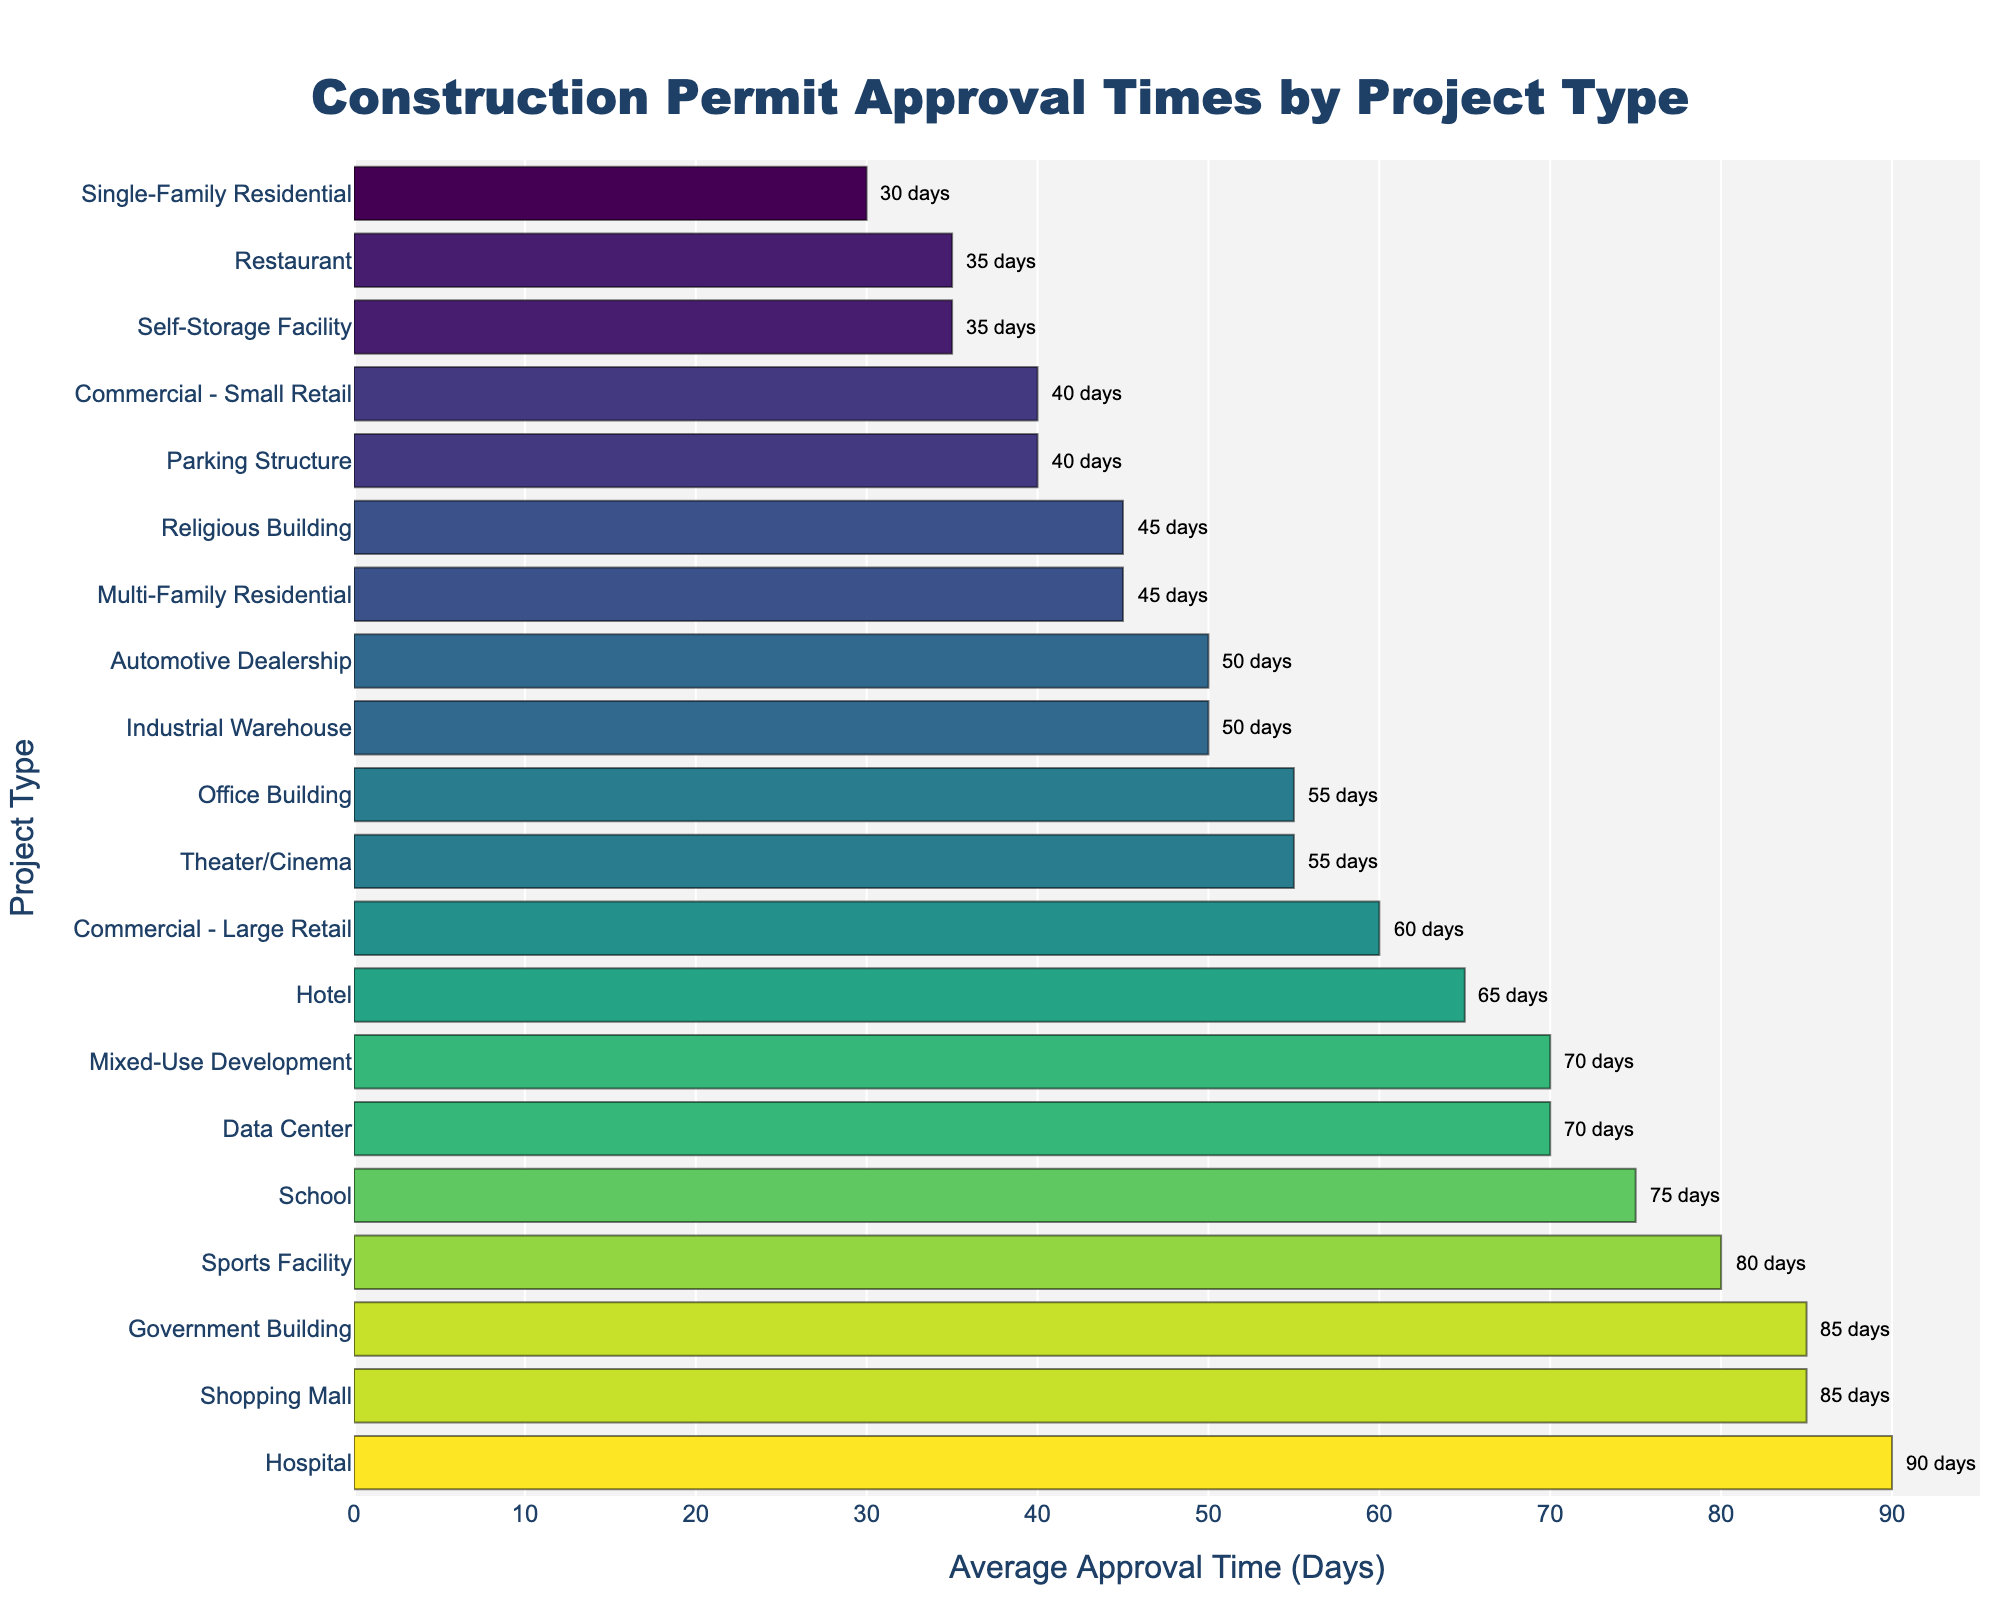Which project type has the shortest average approval time? The figure shows the average approval times for various project types, with the shortest bar representing the shortest time. Single-Family Residential has the shortest approval time at 30 days.
Answer: Single-Family Residential Which project type has the longest average approval time? By looking at the longest bar in the figure, Hospital stands out with the longest approval time at 90 days.
Answer: Hospital What is the difference in approval time between a Commercial - Small Retail and a Commercial - Large Retail project? The average approval time for Commercial - Small Retail is 40 days and for Commercial - Large Retail is 60 days. The difference is 60 - 40 = 20 days.
Answer: 20 days How does the average approval time for Office Building compare to Theater/Cinema? The figure indicates that the Office Building has an average approval time of 55 days, matching that of the Theater/Cinema.
Answer: Equal What is the total approval time for a Hospital, School, and Sports Facility combined? The figure shows the approval times as 90 days for a Hospital, 75 days for a School, and 80 days for a Sports Facility. Summing them gives 90 + 75 + 80 = 245 days.
Answer: 245 days Are there more project types with approval times greater than 50 days or less than 50 days? Visually count the bars for each group. Projects with times greater than 50 days: 10 (Multi-Family Residential, Large Retail, Office Building, Warehouse, School, Hospital, Hotel, Mixed-Use, Sports Facility, Government, Shopping Mall, Theater). Projects with times less than 50 days: 7 (Single-Family, Small Retail, Restaurant, Parking, Religious, Automotive Dealership, Self-Storage). There are more projects with times greater than 50 days.
Answer: Greater than 50 days What is the average approval time for all project types combined? Add up all individual approval times shown in the figure and divide by the number of project types. The approval times are: 30 + 45 + 40 + 60 + 55 + 50 + 75 + 90 + 65 + 35 + 70 + 80 + 45 + 40 + 85 + 70 + 85 + 55 + 50 + 35. Summing all these gives 1200. There are 20 project types, so the average is 1200 / 20 = 60 days.
Answer: 60 days Is the approval time for a Data Center closer to the approval time for a Shopping Mall or a Sports Facility? The approval time for a Data Center is 70 days. Shopping Mall is 85 days and Sports Facility is 80 days. Calculate the differences: 85 - 70 = 15 days for a Shopping Mall and 80 - 70 = 10 days for a Sports Facility. The Data Center is closer to the Sports Facility.
Answer: Sports Facility 